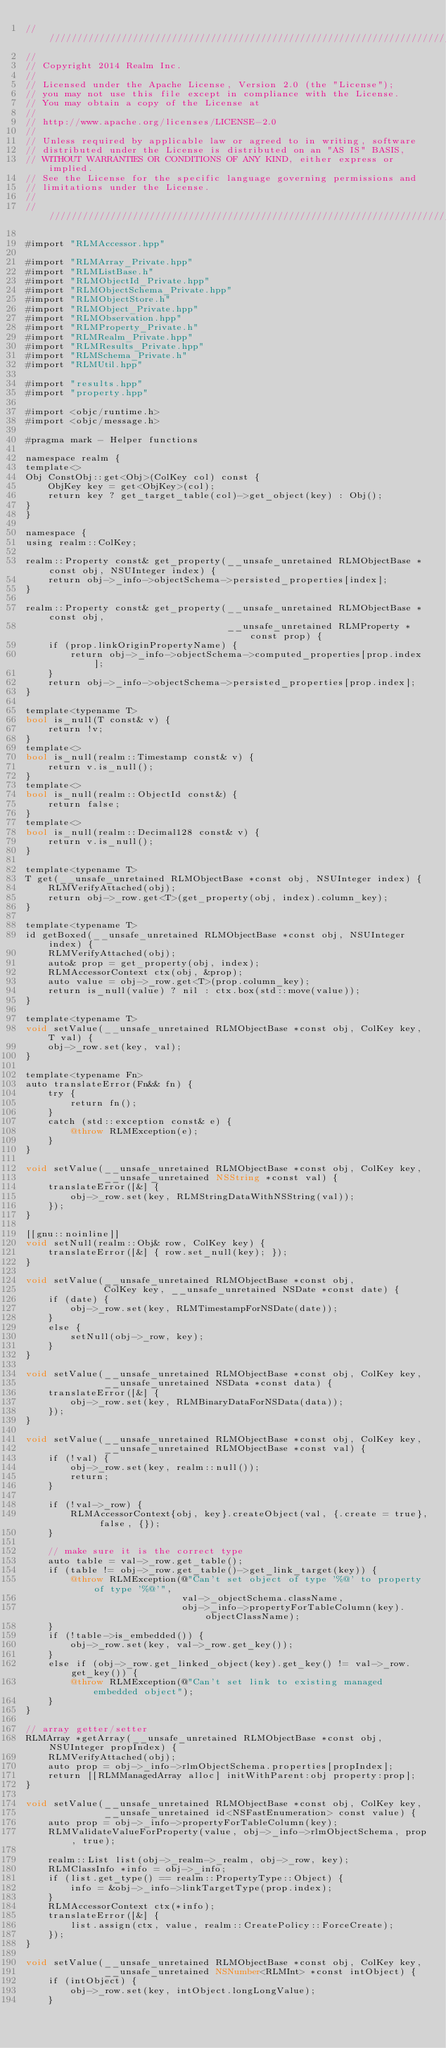<code> <loc_0><loc_0><loc_500><loc_500><_ObjectiveC_>////////////////////////////////////////////////////////////////////////////
//
// Copyright 2014 Realm Inc.
//
// Licensed under the Apache License, Version 2.0 (the "License");
// you may not use this file except in compliance with the License.
// You may obtain a copy of the License at
//
// http://www.apache.org/licenses/LICENSE-2.0
//
// Unless required by applicable law or agreed to in writing, software
// distributed under the License is distributed on an "AS IS" BASIS,
// WITHOUT WARRANTIES OR CONDITIONS OF ANY KIND, either express or implied.
// See the License for the specific language governing permissions and
// limitations under the License.
//
////////////////////////////////////////////////////////////////////////////

#import "RLMAccessor.hpp"

#import "RLMArray_Private.hpp"
#import "RLMListBase.h"
#import "RLMObjectId_Private.hpp"
#import "RLMObjectSchema_Private.hpp"
#import "RLMObjectStore.h"
#import "RLMObject_Private.hpp"
#import "RLMObservation.hpp"
#import "RLMProperty_Private.h"
#import "RLMRealm_Private.hpp"
#import "RLMResults_Private.hpp"
#import "RLMSchema_Private.h"
#import "RLMUtil.hpp"

#import "results.hpp"
#import "property.hpp"

#import <objc/runtime.h>
#import <objc/message.h>

#pragma mark - Helper functions

namespace realm {
template<>
Obj ConstObj::get<Obj>(ColKey col) const {
    ObjKey key = get<ObjKey>(col);
    return key ? get_target_table(col)->get_object(key) : Obj();
}
}

namespace {
using realm::ColKey;

realm::Property const& get_property(__unsafe_unretained RLMObjectBase *const obj, NSUInteger index) {
    return obj->_info->objectSchema->persisted_properties[index];
}

realm::Property const& get_property(__unsafe_unretained RLMObjectBase *const obj,
                                    __unsafe_unretained RLMProperty *const prop) {
    if (prop.linkOriginPropertyName) {
        return obj->_info->objectSchema->computed_properties[prop.index];
    }
    return obj->_info->objectSchema->persisted_properties[prop.index];
}

template<typename T>
bool is_null(T const& v) {
    return !v;
}
template<>
bool is_null(realm::Timestamp const& v) {
    return v.is_null();
}
template<>
bool is_null(realm::ObjectId const&) {
    return false;
}
template<>
bool is_null(realm::Decimal128 const& v) {
    return v.is_null();
}

template<typename T>
T get(__unsafe_unretained RLMObjectBase *const obj, NSUInteger index) {
    RLMVerifyAttached(obj);
    return obj->_row.get<T>(get_property(obj, index).column_key);
}

template<typename T>
id getBoxed(__unsafe_unretained RLMObjectBase *const obj, NSUInteger index) {
    RLMVerifyAttached(obj);
    auto& prop = get_property(obj, index);
    RLMAccessorContext ctx(obj, &prop);
    auto value = obj->_row.get<T>(prop.column_key);
    return is_null(value) ? nil : ctx.box(std::move(value));
}

template<typename T>
void setValue(__unsafe_unretained RLMObjectBase *const obj, ColKey key, T val) {
    obj->_row.set(key, val);
}

template<typename Fn>
auto translateError(Fn&& fn) {
    try {
        return fn();
    }
    catch (std::exception const& e) {
        @throw RLMException(e);
    }
}

void setValue(__unsafe_unretained RLMObjectBase *const obj, ColKey key,
              __unsafe_unretained NSString *const val) {
    translateError([&] {
        obj->_row.set(key, RLMStringDataWithNSString(val));
    });
}

[[gnu::noinline]]
void setNull(realm::Obj& row, ColKey key) {
    translateError([&] { row.set_null(key); });
}

void setValue(__unsafe_unretained RLMObjectBase *const obj,
              ColKey key, __unsafe_unretained NSDate *const date) {
    if (date) {
        obj->_row.set(key, RLMTimestampForNSDate(date));
    }
    else {
        setNull(obj->_row, key);
    }
}

void setValue(__unsafe_unretained RLMObjectBase *const obj, ColKey key,
              __unsafe_unretained NSData *const data) {
    translateError([&] {
        obj->_row.set(key, RLMBinaryDataForNSData(data));
    });
}

void setValue(__unsafe_unretained RLMObjectBase *const obj, ColKey key,
              __unsafe_unretained RLMObjectBase *const val) {
    if (!val) {
        obj->_row.set(key, realm::null());
        return;
    }

    if (!val->_row) {
        RLMAccessorContext{obj, key}.createObject(val, {.create = true}, false, {});
    }

    // make sure it is the correct type
    auto table = val->_row.get_table();
    if (table != obj->_row.get_table()->get_link_target(key)) {
        @throw RLMException(@"Can't set object of type '%@' to property of type '%@'",
                            val->_objectSchema.className,
                            obj->_info->propertyForTableColumn(key).objectClassName);
    }
    if (!table->is_embedded()) {
        obj->_row.set(key, val->_row.get_key());
    }
    else if (obj->_row.get_linked_object(key).get_key() != val->_row.get_key()) {
        @throw RLMException(@"Can't set link to existing managed embedded object");
    }
}

// array getter/setter
RLMArray *getArray(__unsafe_unretained RLMObjectBase *const obj, NSUInteger propIndex) {
    RLMVerifyAttached(obj);
    auto prop = obj->_info->rlmObjectSchema.properties[propIndex];
    return [[RLMManagedArray alloc] initWithParent:obj property:prop];
}

void setValue(__unsafe_unretained RLMObjectBase *const obj, ColKey key,
              __unsafe_unretained id<NSFastEnumeration> const value) {
    auto prop = obj->_info->propertyForTableColumn(key);
    RLMValidateValueForProperty(value, obj->_info->rlmObjectSchema, prop, true);

    realm::List list(obj->_realm->_realm, obj->_row, key);
    RLMClassInfo *info = obj->_info;
    if (list.get_type() == realm::PropertyType::Object) {
        info = &obj->_info->linkTargetType(prop.index);
    }
    RLMAccessorContext ctx(*info);
    translateError([&] {
        list.assign(ctx, value, realm::CreatePolicy::ForceCreate);
    });
}

void setValue(__unsafe_unretained RLMObjectBase *const obj, ColKey key,
              __unsafe_unretained NSNumber<RLMInt> *const intObject) {
    if (intObject) {
        obj->_row.set(key, intObject.longLongValue);
    }</code> 